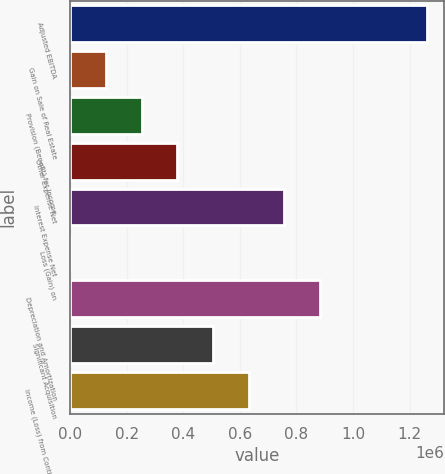Convert chart to OTSL. <chart><loc_0><loc_0><loc_500><loc_500><bar_chart><fcel>Adjusted EBITDA<fcel>Gain on Sale of Real Estate<fcel>Provision (Benefit) for Income<fcel>Other Expense Net<fcel>Interest Expense Net<fcel>Loss (Gain) on<fcel>Depreciation and Amortization<fcel>Significant Acquisition<fcel>Income (Loss) from Continuing<nl><fcel>1.2602e+06<fcel>126739<fcel>252678<fcel>378618<fcel>756437<fcel>799<fcel>882377<fcel>504558<fcel>630498<nl></chart> 